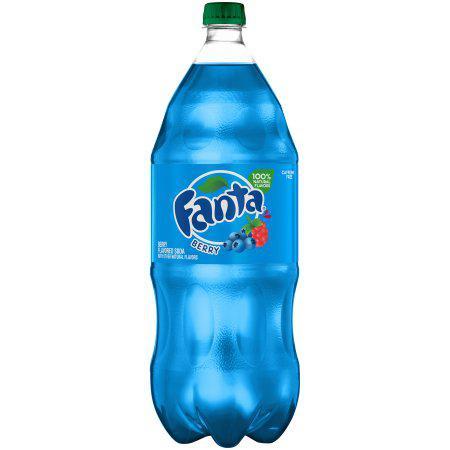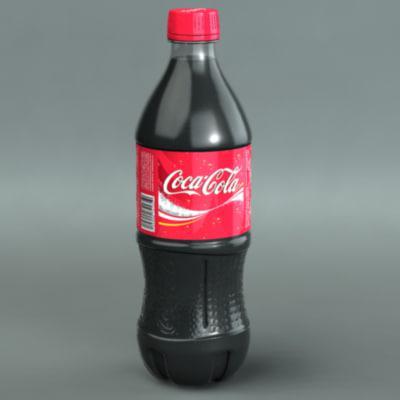The first image is the image on the left, the second image is the image on the right. Assess this claim about the two images: "One of the images shows at least one bottle of Coca-Cola.". Correct or not? Answer yes or no. Yes. The first image is the image on the left, the second image is the image on the right. Given the left and right images, does the statement "There is one bottle in one of the images, and three in the other." hold true? Answer yes or no. No. 